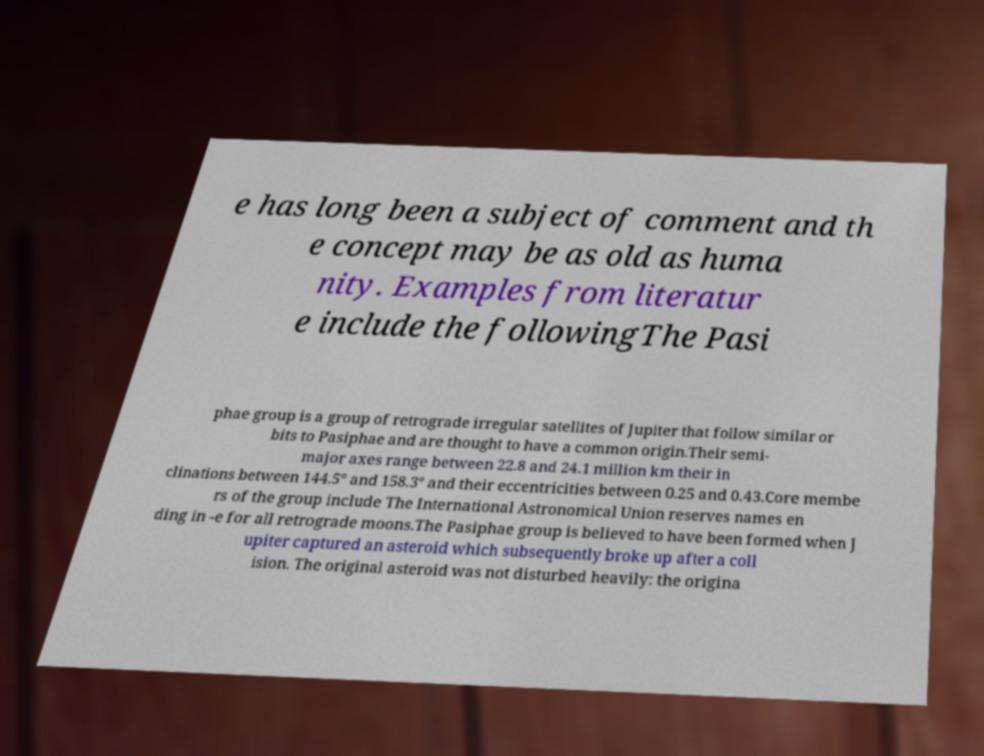Can you read and provide the text displayed in the image?This photo seems to have some interesting text. Can you extract and type it out for me? e has long been a subject of comment and th e concept may be as old as huma nity. Examples from literatur e include the followingThe Pasi phae group is a group of retrograde irregular satellites of Jupiter that follow similar or bits to Pasiphae and are thought to have a common origin.Their semi- major axes range between 22.8 and 24.1 million km their in clinations between 144.5° and 158.3° and their eccentricities between 0.25 and 0.43.Core membe rs of the group include The International Astronomical Union reserves names en ding in -e for all retrograde moons.The Pasiphae group is believed to have been formed when J upiter captured an asteroid which subsequently broke up after a coll ision. The original asteroid was not disturbed heavily: the origina 